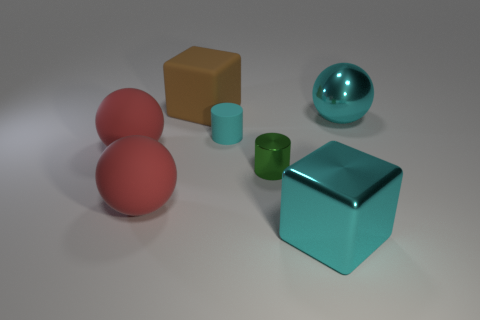Add 3 small green shiny objects. How many objects exist? 10 Subtract all cyan balls. How many balls are left? 2 Subtract all cyan balls. How many balls are left? 2 Subtract all blocks. How many objects are left? 5 Add 2 large cyan metallic things. How many large cyan metallic things exist? 4 Subtract 0 yellow cubes. How many objects are left? 7 Subtract 3 spheres. How many spheres are left? 0 Subtract all blue blocks. Subtract all blue spheres. How many blocks are left? 2 Subtract all brown blocks. How many purple balls are left? 0 Subtract all large brown things. Subtract all big matte blocks. How many objects are left? 5 